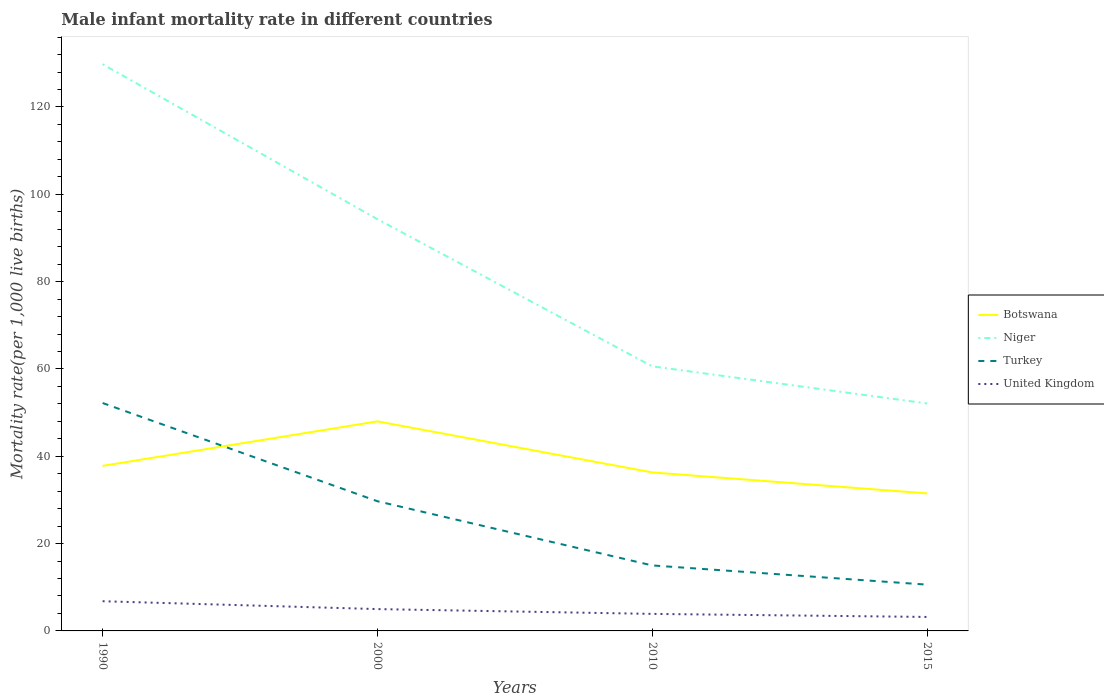How many different coloured lines are there?
Make the answer very short. 4. Does the line corresponding to Botswana intersect with the line corresponding to United Kingdom?
Give a very brief answer. No. Across all years, what is the maximum male infant mortality rate in Botswana?
Provide a succinct answer. 31.5. In which year was the male infant mortality rate in Botswana maximum?
Give a very brief answer. 2015. What is the difference between the highest and the second highest male infant mortality rate in Botswana?
Give a very brief answer. 16.5. Is the male infant mortality rate in Niger strictly greater than the male infant mortality rate in Turkey over the years?
Offer a very short reply. No. What is the difference between two consecutive major ticks on the Y-axis?
Your answer should be very brief. 20. Does the graph contain any zero values?
Provide a succinct answer. No. Does the graph contain grids?
Provide a succinct answer. No. How are the legend labels stacked?
Provide a succinct answer. Vertical. What is the title of the graph?
Give a very brief answer. Male infant mortality rate in different countries. Does "Estonia" appear as one of the legend labels in the graph?
Provide a succinct answer. No. What is the label or title of the Y-axis?
Keep it short and to the point. Mortality rate(per 1,0 live births). What is the Mortality rate(per 1,000 live births) of Botswana in 1990?
Your answer should be compact. 37.8. What is the Mortality rate(per 1,000 live births) of Niger in 1990?
Your answer should be compact. 129.8. What is the Mortality rate(per 1,000 live births) in Turkey in 1990?
Make the answer very short. 52.2. What is the Mortality rate(per 1,000 live births) in Botswana in 2000?
Make the answer very short. 48. What is the Mortality rate(per 1,000 live births) in Niger in 2000?
Make the answer very short. 94.3. What is the Mortality rate(per 1,000 live births) of Turkey in 2000?
Your answer should be compact. 29.7. What is the Mortality rate(per 1,000 live births) of Botswana in 2010?
Offer a terse response. 36.3. What is the Mortality rate(per 1,000 live births) of Niger in 2010?
Give a very brief answer. 60.6. What is the Mortality rate(per 1,000 live births) of Turkey in 2010?
Your answer should be compact. 15. What is the Mortality rate(per 1,000 live births) in United Kingdom in 2010?
Your response must be concise. 3.9. What is the Mortality rate(per 1,000 live births) of Botswana in 2015?
Keep it short and to the point. 31.5. What is the Mortality rate(per 1,000 live births) of Niger in 2015?
Your answer should be compact. 52.1. What is the Mortality rate(per 1,000 live births) in Turkey in 2015?
Provide a succinct answer. 10.6. What is the Mortality rate(per 1,000 live births) in United Kingdom in 2015?
Provide a succinct answer. 3.2. Across all years, what is the maximum Mortality rate(per 1,000 live births) in Niger?
Provide a succinct answer. 129.8. Across all years, what is the maximum Mortality rate(per 1,000 live births) of Turkey?
Ensure brevity in your answer.  52.2. Across all years, what is the maximum Mortality rate(per 1,000 live births) of United Kingdom?
Offer a very short reply. 6.8. Across all years, what is the minimum Mortality rate(per 1,000 live births) in Botswana?
Make the answer very short. 31.5. Across all years, what is the minimum Mortality rate(per 1,000 live births) in Niger?
Ensure brevity in your answer.  52.1. Across all years, what is the minimum Mortality rate(per 1,000 live births) of Turkey?
Keep it short and to the point. 10.6. What is the total Mortality rate(per 1,000 live births) of Botswana in the graph?
Your response must be concise. 153.6. What is the total Mortality rate(per 1,000 live births) of Niger in the graph?
Offer a very short reply. 336.8. What is the total Mortality rate(per 1,000 live births) in Turkey in the graph?
Provide a short and direct response. 107.5. What is the total Mortality rate(per 1,000 live births) in United Kingdom in the graph?
Offer a very short reply. 18.9. What is the difference between the Mortality rate(per 1,000 live births) in Botswana in 1990 and that in 2000?
Provide a short and direct response. -10.2. What is the difference between the Mortality rate(per 1,000 live births) in Niger in 1990 and that in 2000?
Offer a very short reply. 35.5. What is the difference between the Mortality rate(per 1,000 live births) of Turkey in 1990 and that in 2000?
Keep it short and to the point. 22.5. What is the difference between the Mortality rate(per 1,000 live births) in United Kingdom in 1990 and that in 2000?
Provide a short and direct response. 1.8. What is the difference between the Mortality rate(per 1,000 live births) of Niger in 1990 and that in 2010?
Provide a succinct answer. 69.2. What is the difference between the Mortality rate(per 1,000 live births) in Turkey in 1990 and that in 2010?
Offer a very short reply. 37.2. What is the difference between the Mortality rate(per 1,000 live births) in Botswana in 1990 and that in 2015?
Offer a terse response. 6.3. What is the difference between the Mortality rate(per 1,000 live births) in Niger in 1990 and that in 2015?
Offer a terse response. 77.7. What is the difference between the Mortality rate(per 1,000 live births) in Turkey in 1990 and that in 2015?
Keep it short and to the point. 41.6. What is the difference between the Mortality rate(per 1,000 live births) of Niger in 2000 and that in 2010?
Offer a terse response. 33.7. What is the difference between the Mortality rate(per 1,000 live births) in Turkey in 2000 and that in 2010?
Provide a succinct answer. 14.7. What is the difference between the Mortality rate(per 1,000 live births) of Botswana in 2000 and that in 2015?
Provide a succinct answer. 16.5. What is the difference between the Mortality rate(per 1,000 live births) of Niger in 2000 and that in 2015?
Your answer should be compact. 42.2. What is the difference between the Mortality rate(per 1,000 live births) of Turkey in 2000 and that in 2015?
Ensure brevity in your answer.  19.1. What is the difference between the Mortality rate(per 1,000 live births) of United Kingdom in 2000 and that in 2015?
Give a very brief answer. 1.8. What is the difference between the Mortality rate(per 1,000 live births) of Niger in 2010 and that in 2015?
Ensure brevity in your answer.  8.5. What is the difference between the Mortality rate(per 1,000 live births) in Turkey in 2010 and that in 2015?
Provide a short and direct response. 4.4. What is the difference between the Mortality rate(per 1,000 live births) in Botswana in 1990 and the Mortality rate(per 1,000 live births) in Niger in 2000?
Ensure brevity in your answer.  -56.5. What is the difference between the Mortality rate(per 1,000 live births) in Botswana in 1990 and the Mortality rate(per 1,000 live births) in Turkey in 2000?
Keep it short and to the point. 8.1. What is the difference between the Mortality rate(per 1,000 live births) of Botswana in 1990 and the Mortality rate(per 1,000 live births) of United Kingdom in 2000?
Provide a short and direct response. 32.8. What is the difference between the Mortality rate(per 1,000 live births) in Niger in 1990 and the Mortality rate(per 1,000 live births) in Turkey in 2000?
Keep it short and to the point. 100.1. What is the difference between the Mortality rate(per 1,000 live births) of Niger in 1990 and the Mortality rate(per 1,000 live births) of United Kingdom in 2000?
Ensure brevity in your answer.  124.8. What is the difference between the Mortality rate(per 1,000 live births) in Turkey in 1990 and the Mortality rate(per 1,000 live births) in United Kingdom in 2000?
Ensure brevity in your answer.  47.2. What is the difference between the Mortality rate(per 1,000 live births) of Botswana in 1990 and the Mortality rate(per 1,000 live births) of Niger in 2010?
Ensure brevity in your answer.  -22.8. What is the difference between the Mortality rate(per 1,000 live births) in Botswana in 1990 and the Mortality rate(per 1,000 live births) in Turkey in 2010?
Make the answer very short. 22.8. What is the difference between the Mortality rate(per 1,000 live births) of Botswana in 1990 and the Mortality rate(per 1,000 live births) of United Kingdom in 2010?
Provide a short and direct response. 33.9. What is the difference between the Mortality rate(per 1,000 live births) in Niger in 1990 and the Mortality rate(per 1,000 live births) in Turkey in 2010?
Keep it short and to the point. 114.8. What is the difference between the Mortality rate(per 1,000 live births) of Niger in 1990 and the Mortality rate(per 1,000 live births) of United Kingdom in 2010?
Make the answer very short. 125.9. What is the difference between the Mortality rate(per 1,000 live births) in Turkey in 1990 and the Mortality rate(per 1,000 live births) in United Kingdom in 2010?
Ensure brevity in your answer.  48.3. What is the difference between the Mortality rate(per 1,000 live births) in Botswana in 1990 and the Mortality rate(per 1,000 live births) in Niger in 2015?
Provide a succinct answer. -14.3. What is the difference between the Mortality rate(per 1,000 live births) in Botswana in 1990 and the Mortality rate(per 1,000 live births) in Turkey in 2015?
Provide a short and direct response. 27.2. What is the difference between the Mortality rate(per 1,000 live births) of Botswana in 1990 and the Mortality rate(per 1,000 live births) of United Kingdom in 2015?
Keep it short and to the point. 34.6. What is the difference between the Mortality rate(per 1,000 live births) in Niger in 1990 and the Mortality rate(per 1,000 live births) in Turkey in 2015?
Keep it short and to the point. 119.2. What is the difference between the Mortality rate(per 1,000 live births) in Niger in 1990 and the Mortality rate(per 1,000 live births) in United Kingdom in 2015?
Give a very brief answer. 126.6. What is the difference between the Mortality rate(per 1,000 live births) in Botswana in 2000 and the Mortality rate(per 1,000 live births) in Niger in 2010?
Give a very brief answer. -12.6. What is the difference between the Mortality rate(per 1,000 live births) of Botswana in 2000 and the Mortality rate(per 1,000 live births) of Turkey in 2010?
Offer a very short reply. 33. What is the difference between the Mortality rate(per 1,000 live births) of Botswana in 2000 and the Mortality rate(per 1,000 live births) of United Kingdom in 2010?
Your answer should be very brief. 44.1. What is the difference between the Mortality rate(per 1,000 live births) of Niger in 2000 and the Mortality rate(per 1,000 live births) of Turkey in 2010?
Provide a short and direct response. 79.3. What is the difference between the Mortality rate(per 1,000 live births) in Niger in 2000 and the Mortality rate(per 1,000 live births) in United Kingdom in 2010?
Provide a short and direct response. 90.4. What is the difference between the Mortality rate(per 1,000 live births) in Turkey in 2000 and the Mortality rate(per 1,000 live births) in United Kingdom in 2010?
Provide a short and direct response. 25.8. What is the difference between the Mortality rate(per 1,000 live births) in Botswana in 2000 and the Mortality rate(per 1,000 live births) in Niger in 2015?
Provide a succinct answer. -4.1. What is the difference between the Mortality rate(per 1,000 live births) of Botswana in 2000 and the Mortality rate(per 1,000 live births) of Turkey in 2015?
Offer a terse response. 37.4. What is the difference between the Mortality rate(per 1,000 live births) in Botswana in 2000 and the Mortality rate(per 1,000 live births) in United Kingdom in 2015?
Give a very brief answer. 44.8. What is the difference between the Mortality rate(per 1,000 live births) of Niger in 2000 and the Mortality rate(per 1,000 live births) of Turkey in 2015?
Your response must be concise. 83.7. What is the difference between the Mortality rate(per 1,000 live births) of Niger in 2000 and the Mortality rate(per 1,000 live births) of United Kingdom in 2015?
Your answer should be very brief. 91.1. What is the difference between the Mortality rate(per 1,000 live births) in Turkey in 2000 and the Mortality rate(per 1,000 live births) in United Kingdom in 2015?
Ensure brevity in your answer.  26.5. What is the difference between the Mortality rate(per 1,000 live births) of Botswana in 2010 and the Mortality rate(per 1,000 live births) of Niger in 2015?
Keep it short and to the point. -15.8. What is the difference between the Mortality rate(per 1,000 live births) of Botswana in 2010 and the Mortality rate(per 1,000 live births) of Turkey in 2015?
Ensure brevity in your answer.  25.7. What is the difference between the Mortality rate(per 1,000 live births) in Botswana in 2010 and the Mortality rate(per 1,000 live births) in United Kingdom in 2015?
Offer a very short reply. 33.1. What is the difference between the Mortality rate(per 1,000 live births) of Niger in 2010 and the Mortality rate(per 1,000 live births) of United Kingdom in 2015?
Your answer should be very brief. 57.4. What is the difference between the Mortality rate(per 1,000 live births) of Turkey in 2010 and the Mortality rate(per 1,000 live births) of United Kingdom in 2015?
Offer a terse response. 11.8. What is the average Mortality rate(per 1,000 live births) of Botswana per year?
Provide a short and direct response. 38.4. What is the average Mortality rate(per 1,000 live births) in Niger per year?
Keep it short and to the point. 84.2. What is the average Mortality rate(per 1,000 live births) of Turkey per year?
Make the answer very short. 26.88. What is the average Mortality rate(per 1,000 live births) in United Kingdom per year?
Keep it short and to the point. 4.72. In the year 1990, what is the difference between the Mortality rate(per 1,000 live births) of Botswana and Mortality rate(per 1,000 live births) of Niger?
Provide a short and direct response. -92. In the year 1990, what is the difference between the Mortality rate(per 1,000 live births) of Botswana and Mortality rate(per 1,000 live births) of Turkey?
Give a very brief answer. -14.4. In the year 1990, what is the difference between the Mortality rate(per 1,000 live births) in Niger and Mortality rate(per 1,000 live births) in Turkey?
Offer a terse response. 77.6. In the year 1990, what is the difference between the Mortality rate(per 1,000 live births) of Niger and Mortality rate(per 1,000 live births) of United Kingdom?
Your answer should be compact. 123. In the year 1990, what is the difference between the Mortality rate(per 1,000 live births) in Turkey and Mortality rate(per 1,000 live births) in United Kingdom?
Provide a short and direct response. 45.4. In the year 2000, what is the difference between the Mortality rate(per 1,000 live births) of Botswana and Mortality rate(per 1,000 live births) of Niger?
Offer a very short reply. -46.3. In the year 2000, what is the difference between the Mortality rate(per 1,000 live births) in Botswana and Mortality rate(per 1,000 live births) in United Kingdom?
Offer a very short reply. 43. In the year 2000, what is the difference between the Mortality rate(per 1,000 live births) in Niger and Mortality rate(per 1,000 live births) in Turkey?
Keep it short and to the point. 64.6. In the year 2000, what is the difference between the Mortality rate(per 1,000 live births) in Niger and Mortality rate(per 1,000 live births) in United Kingdom?
Ensure brevity in your answer.  89.3. In the year 2000, what is the difference between the Mortality rate(per 1,000 live births) of Turkey and Mortality rate(per 1,000 live births) of United Kingdom?
Provide a succinct answer. 24.7. In the year 2010, what is the difference between the Mortality rate(per 1,000 live births) of Botswana and Mortality rate(per 1,000 live births) of Niger?
Your answer should be very brief. -24.3. In the year 2010, what is the difference between the Mortality rate(per 1,000 live births) in Botswana and Mortality rate(per 1,000 live births) in Turkey?
Provide a short and direct response. 21.3. In the year 2010, what is the difference between the Mortality rate(per 1,000 live births) of Botswana and Mortality rate(per 1,000 live births) of United Kingdom?
Make the answer very short. 32.4. In the year 2010, what is the difference between the Mortality rate(per 1,000 live births) in Niger and Mortality rate(per 1,000 live births) in Turkey?
Your response must be concise. 45.6. In the year 2010, what is the difference between the Mortality rate(per 1,000 live births) of Niger and Mortality rate(per 1,000 live births) of United Kingdom?
Offer a terse response. 56.7. In the year 2015, what is the difference between the Mortality rate(per 1,000 live births) of Botswana and Mortality rate(per 1,000 live births) of Niger?
Your answer should be compact. -20.6. In the year 2015, what is the difference between the Mortality rate(per 1,000 live births) of Botswana and Mortality rate(per 1,000 live births) of Turkey?
Give a very brief answer. 20.9. In the year 2015, what is the difference between the Mortality rate(per 1,000 live births) in Botswana and Mortality rate(per 1,000 live births) in United Kingdom?
Your response must be concise. 28.3. In the year 2015, what is the difference between the Mortality rate(per 1,000 live births) in Niger and Mortality rate(per 1,000 live births) in Turkey?
Offer a very short reply. 41.5. In the year 2015, what is the difference between the Mortality rate(per 1,000 live births) in Niger and Mortality rate(per 1,000 live births) in United Kingdom?
Your answer should be very brief. 48.9. In the year 2015, what is the difference between the Mortality rate(per 1,000 live births) in Turkey and Mortality rate(per 1,000 live births) in United Kingdom?
Offer a terse response. 7.4. What is the ratio of the Mortality rate(per 1,000 live births) of Botswana in 1990 to that in 2000?
Keep it short and to the point. 0.79. What is the ratio of the Mortality rate(per 1,000 live births) in Niger in 1990 to that in 2000?
Give a very brief answer. 1.38. What is the ratio of the Mortality rate(per 1,000 live births) in Turkey in 1990 to that in 2000?
Your answer should be compact. 1.76. What is the ratio of the Mortality rate(per 1,000 live births) in United Kingdom in 1990 to that in 2000?
Make the answer very short. 1.36. What is the ratio of the Mortality rate(per 1,000 live births) in Botswana in 1990 to that in 2010?
Your answer should be very brief. 1.04. What is the ratio of the Mortality rate(per 1,000 live births) in Niger in 1990 to that in 2010?
Make the answer very short. 2.14. What is the ratio of the Mortality rate(per 1,000 live births) in Turkey in 1990 to that in 2010?
Your answer should be very brief. 3.48. What is the ratio of the Mortality rate(per 1,000 live births) in United Kingdom in 1990 to that in 2010?
Your response must be concise. 1.74. What is the ratio of the Mortality rate(per 1,000 live births) in Botswana in 1990 to that in 2015?
Offer a terse response. 1.2. What is the ratio of the Mortality rate(per 1,000 live births) of Niger in 1990 to that in 2015?
Keep it short and to the point. 2.49. What is the ratio of the Mortality rate(per 1,000 live births) of Turkey in 1990 to that in 2015?
Ensure brevity in your answer.  4.92. What is the ratio of the Mortality rate(per 1,000 live births) in United Kingdom in 1990 to that in 2015?
Keep it short and to the point. 2.12. What is the ratio of the Mortality rate(per 1,000 live births) in Botswana in 2000 to that in 2010?
Offer a very short reply. 1.32. What is the ratio of the Mortality rate(per 1,000 live births) in Niger in 2000 to that in 2010?
Your answer should be compact. 1.56. What is the ratio of the Mortality rate(per 1,000 live births) in Turkey in 2000 to that in 2010?
Your answer should be very brief. 1.98. What is the ratio of the Mortality rate(per 1,000 live births) in United Kingdom in 2000 to that in 2010?
Offer a very short reply. 1.28. What is the ratio of the Mortality rate(per 1,000 live births) of Botswana in 2000 to that in 2015?
Your answer should be very brief. 1.52. What is the ratio of the Mortality rate(per 1,000 live births) in Niger in 2000 to that in 2015?
Keep it short and to the point. 1.81. What is the ratio of the Mortality rate(per 1,000 live births) in Turkey in 2000 to that in 2015?
Provide a short and direct response. 2.8. What is the ratio of the Mortality rate(per 1,000 live births) of United Kingdom in 2000 to that in 2015?
Provide a short and direct response. 1.56. What is the ratio of the Mortality rate(per 1,000 live births) in Botswana in 2010 to that in 2015?
Offer a terse response. 1.15. What is the ratio of the Mortality rate(per 1,000 live births) in Niger in 2010 to that in 2015?
Offer a terse response. 1.16. What is the ratio of the Mortality rate(per 1,000 live births) of Turkey in 2010 to that in 2015?
Your answer should be very brief. 1.42. What is the ratio of the Mortality rate(per 1,000 live births) of United Kingdom in 2010 to that in 2015?
Your answer should be very brief. 1.22. What is the difference between the highest and the second highest Mortality rate(per 1,000 live births) in Botswana?
Ensure brevity in your answer.  10.2. What is the difference between the highest and the second highest Mortality rate(per 1,000 live births) of Niger?
Offer a terse response. 35.5. What is the difference between the highest and the second highest Mortality rate(per 1,000 live births) of United Kingdom?
Offer a very short reply. 1.8. What is the difference between the highest and the lowest Mortality rate(per 1,000 live births) in Botswana?
Keep it short and to the point. 16.5. What is the difference between the highest and the lowest Mortality rate(per 1,000 live births) in Niger?
Offer a very short reply. 77.7. What is the difference between the highest and the lowest Mortality rate(per 1,000 live births) of Turkey?
Your response must be concise. 41.6. What is the difference between the highest and the lowest Mortality rate(per 1,000 live births) in United Kingdom?
Offer a very short reply. 3.6. 